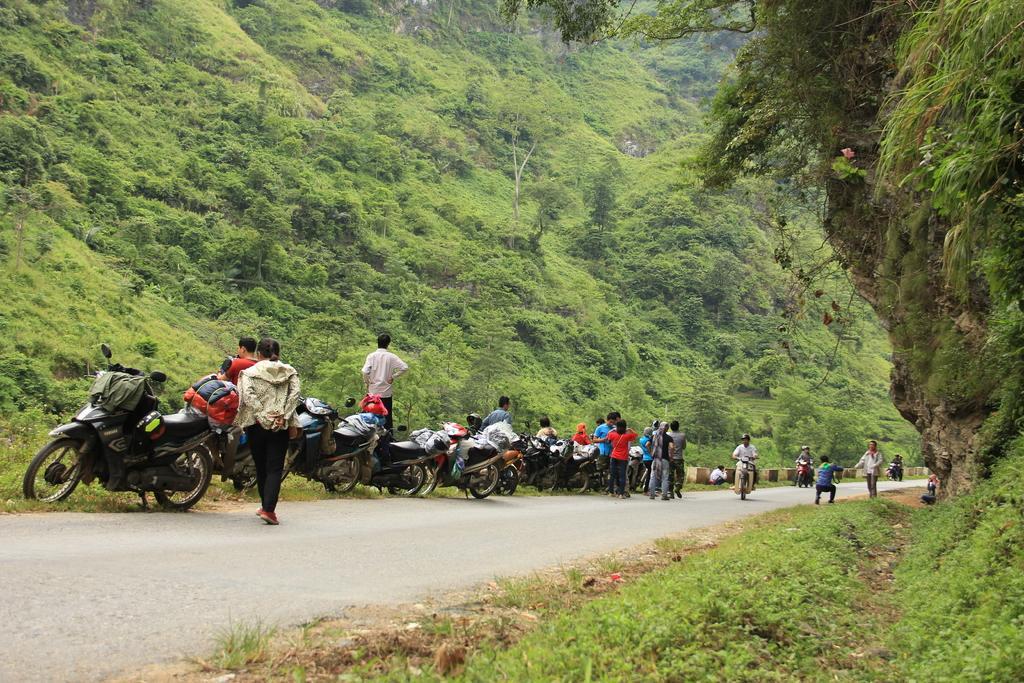Describe this image in one or two sentences. In this image I can see the road, few motorbikes on the road and few persons on the road. I can see some grass and few trees on both sides of the road. 